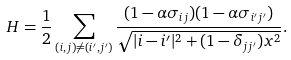Convert formula to latex. <formula><loc_0><loc_0><loc_500><loc_500>H = \frac { 1 } { 2 } \sum _ { ( i , j ) \neq ( i ^ { \prime } , j ^ { \prime } ) } \frac { ( 1 - \alpha \sigma _ { i j } ) ( 1 - \alpha \sigma _ { i ^ { \prime } j ^ { \prime } } ) } { \sqrt { | i - i ^ { \prime } | ^ { 2 } + ( 1 - \delta _ { j j ^ { \prime } } ) x ^ { 2 } } } .</formula> 